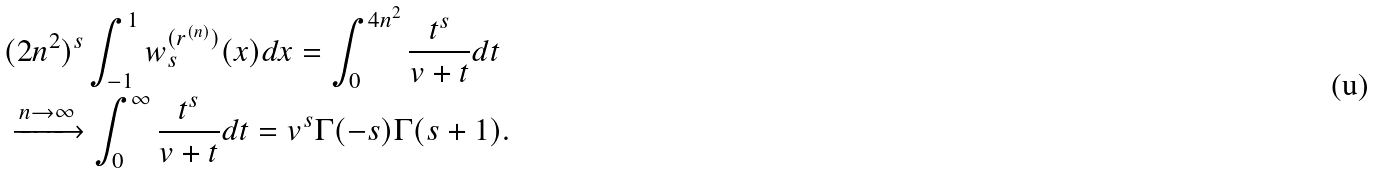<formula> <loc_0><loc_0><loc_500><loc_500>& ( 2 n ^ { 2 } ) ^ { s } \int _ { - 1 } ^ { 1 } w _ { s } ^ { ( r ^ { ( n ) } ) } ( x ) d x = \int _ { 0 } ^ { 4 n ^ { 2 } } \frac { t ^ { s } } { v + t } d t \\ & \xrightarrow { n \to \infty } \int _ { 0 } ^ { \infty } \frac { t ^ { s } } { v + t } d t = v ^ { s } \Gamma ( - s ) \Gamma ( s + 1 ) .</formula> 